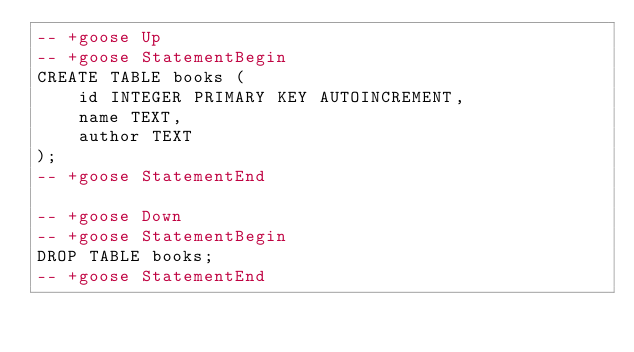<code> <loc_0><loc_0><loc_500><loc_500><_SQL_>-- +goose Up
-- +goose StatementBegin
CREATE TABLE books (
    id INTEGER PRIMARY KEY AUTOINCREMENT,
    name TEXT,
    author TEXT
);
-- +goose StatementEnd

-- +goose Down
-- +goose StatementBegin
DROP TABLE books;
-- +goose StatementEnd
</code> 